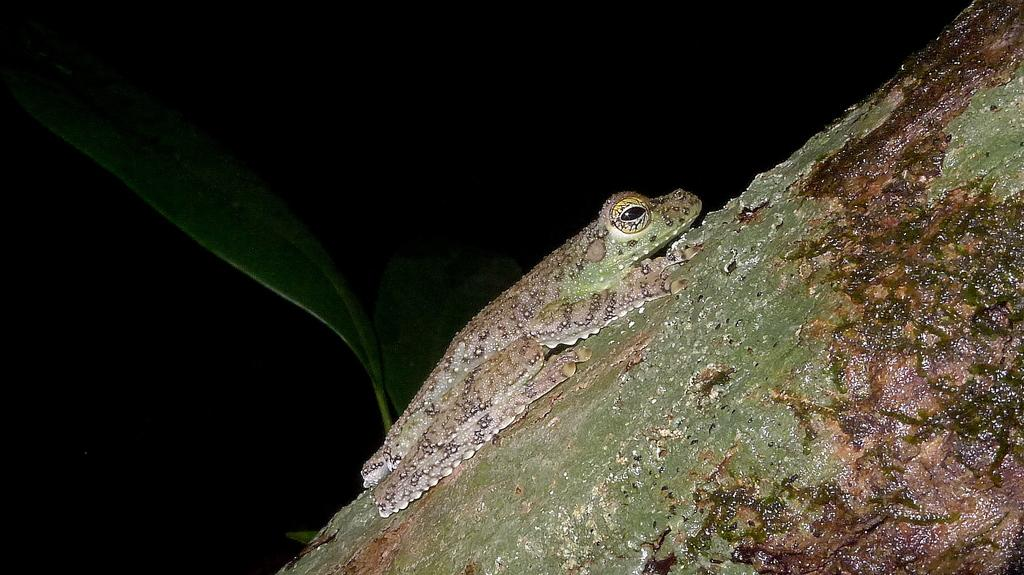What is the main subject in the middle of the image? There is a frog in the middle of the image. What can be seen on the left side of the image? There is a leaf on the left side of the image. What type of produce is being weighed in the image? There is no produce present in the image; it features a frog and a leaf. What arithmetic problem is being solved in the image? There is no arithmetic problem present in the image; it features a frog and a leaf. 